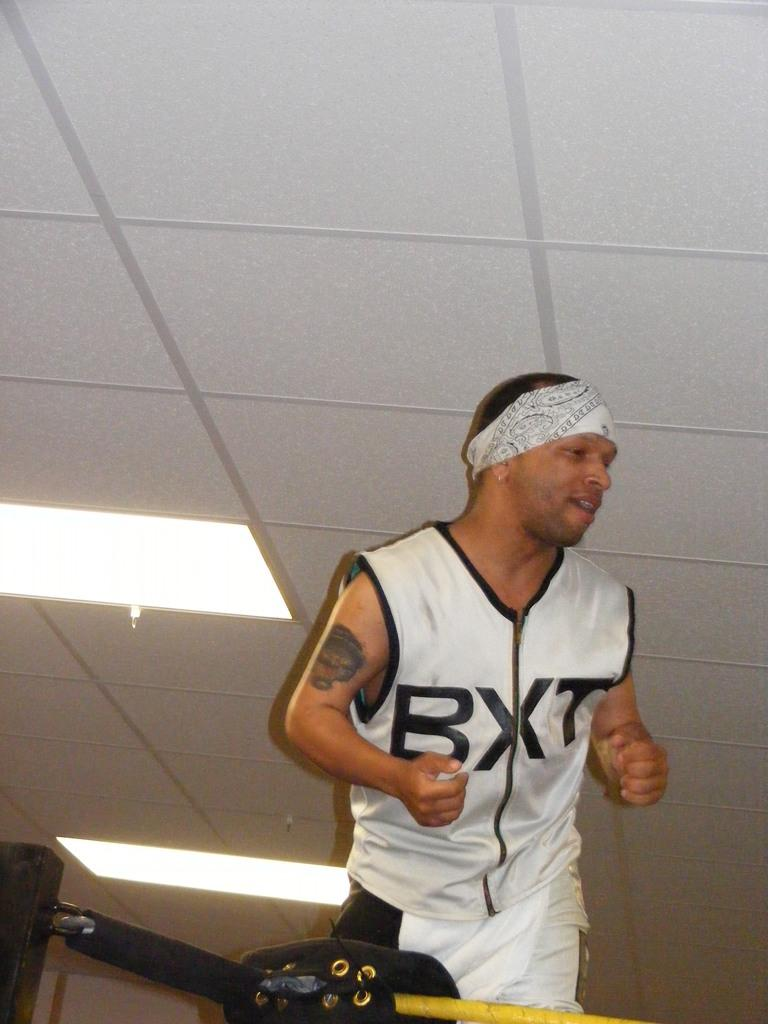<image>
Describe the image concisely. man with bxt jersey running on a treadmill 